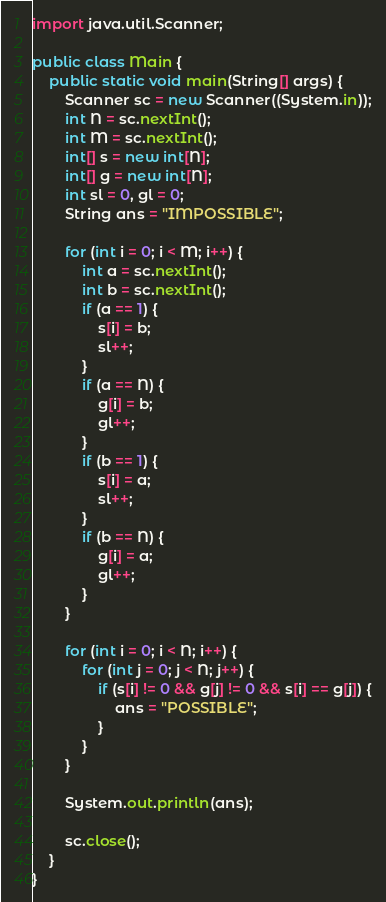Convert code to text. <code><loc_0><loc_0><loc_500><loc_500><_Java_>import java.util.Scanner;

public class Main {
	public static void main(String[] args) {
		Scanner sc = new Scanner((System.in));
		int N = sc.nextInt();
		int M = sc.nextInt();
		int[] s = new int[N];
		int[] g = new int[N];
		int sl = 0, gl = 0;
		String ans = "IMPOSSIBLE";
		
		for (int i = 0; i < M; i++) {
			int a = sc.nextInt();
			int b = sc.nextInt();
			if (a == 1) {
				s[i] = b;
				sl++;
			}
			if (a == N) {
				g[i] = b;
				gl++;
			}
			if (b == 1) {
				s[i] = a;
				sl++;
			}
			if (b == N) {
				g[i] = a;
				gl++;
			}
		}
		
		for (int i = 0; i < N; i++) {
			for (int j = 0; j < N; j++) {
				if (s[i] != 0 && g[j] != 0 && s[i] == g[j]) {
					ans = "POSSIBLE";
				}
			}
		}

		System.out.println(ans);

		sc.close();
	}
}
</code> 